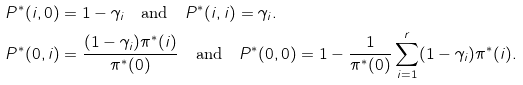Convert formula to latex. <formula><loc_0><loc_0><loc_500><loc_500>P ^ { * } ( i , 0 ) & = 1 - \gamma _ { i } \quad \text {and} \quad P ^ { * } ( i , i ) = \gamma _ { i } . \\ P ^ { * } ( 0 , i ) & = \frac { ( 1 - \gamma _ { i } ) \pi ^ { * } ( i ) } { \pi ^ { * } ( 0 ) } \quad \text {and} \quad P ^ { * } ( 0 , 0 ) = 1 - \frac { 1 } { \pi ^ { * } ( 0 ) } \sum _ { i = 1 } ^ { r } ( 1 - \gamma _ { i } ) \pi ^ { * } ( i ) .</formula> 